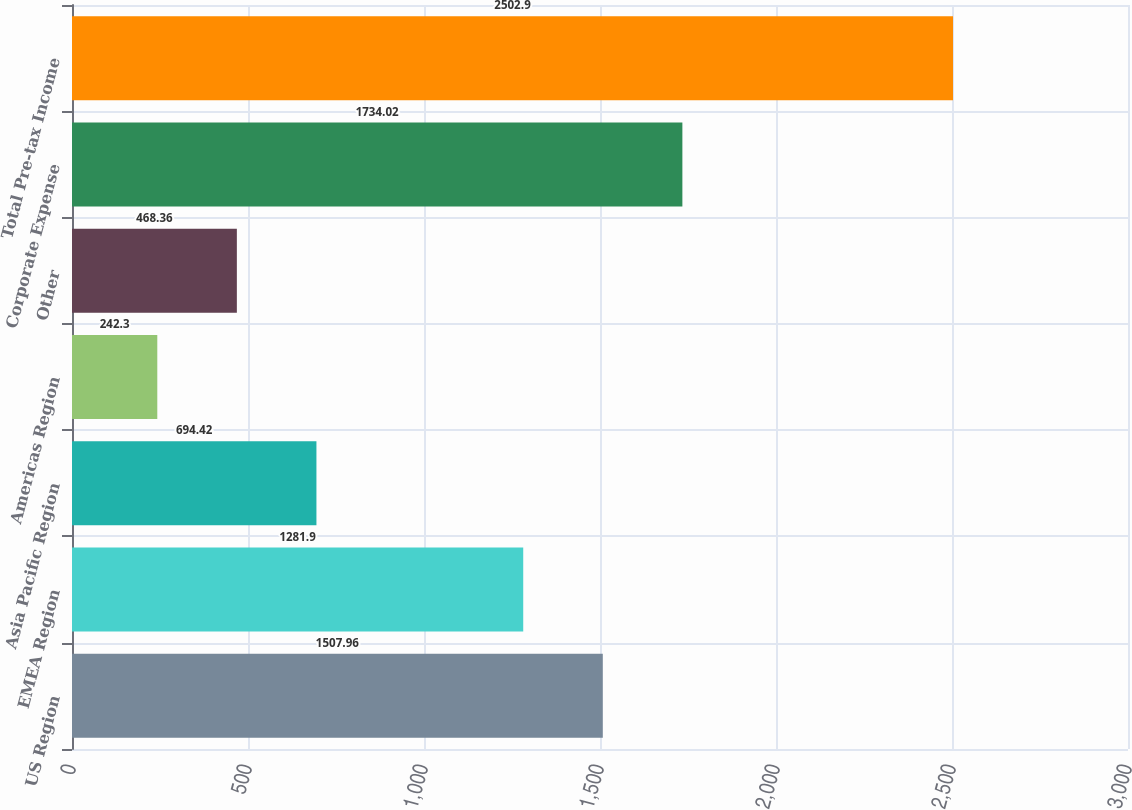<chart> <loc_0><loc_0><loc_500><loc_500><bar_chart><fcel>US Region<fcel>EMEA Region<fcel>Asia Pacific Region<fcel>Americas Region<fcel>Other<fcel>Corporate Expense<fcel>Total Pre-tax Income<nl><fcel>1507.96<fcel>1281.9<fcel>694.42<fcel>242.3<fcel>468.36<fcel>1734.02<fcel>2502.9<nl></chart> 